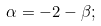<formula> <loc_0><loc_0><loc_500><loc_500>\alpha = - 2 - \beta ;</formula> 